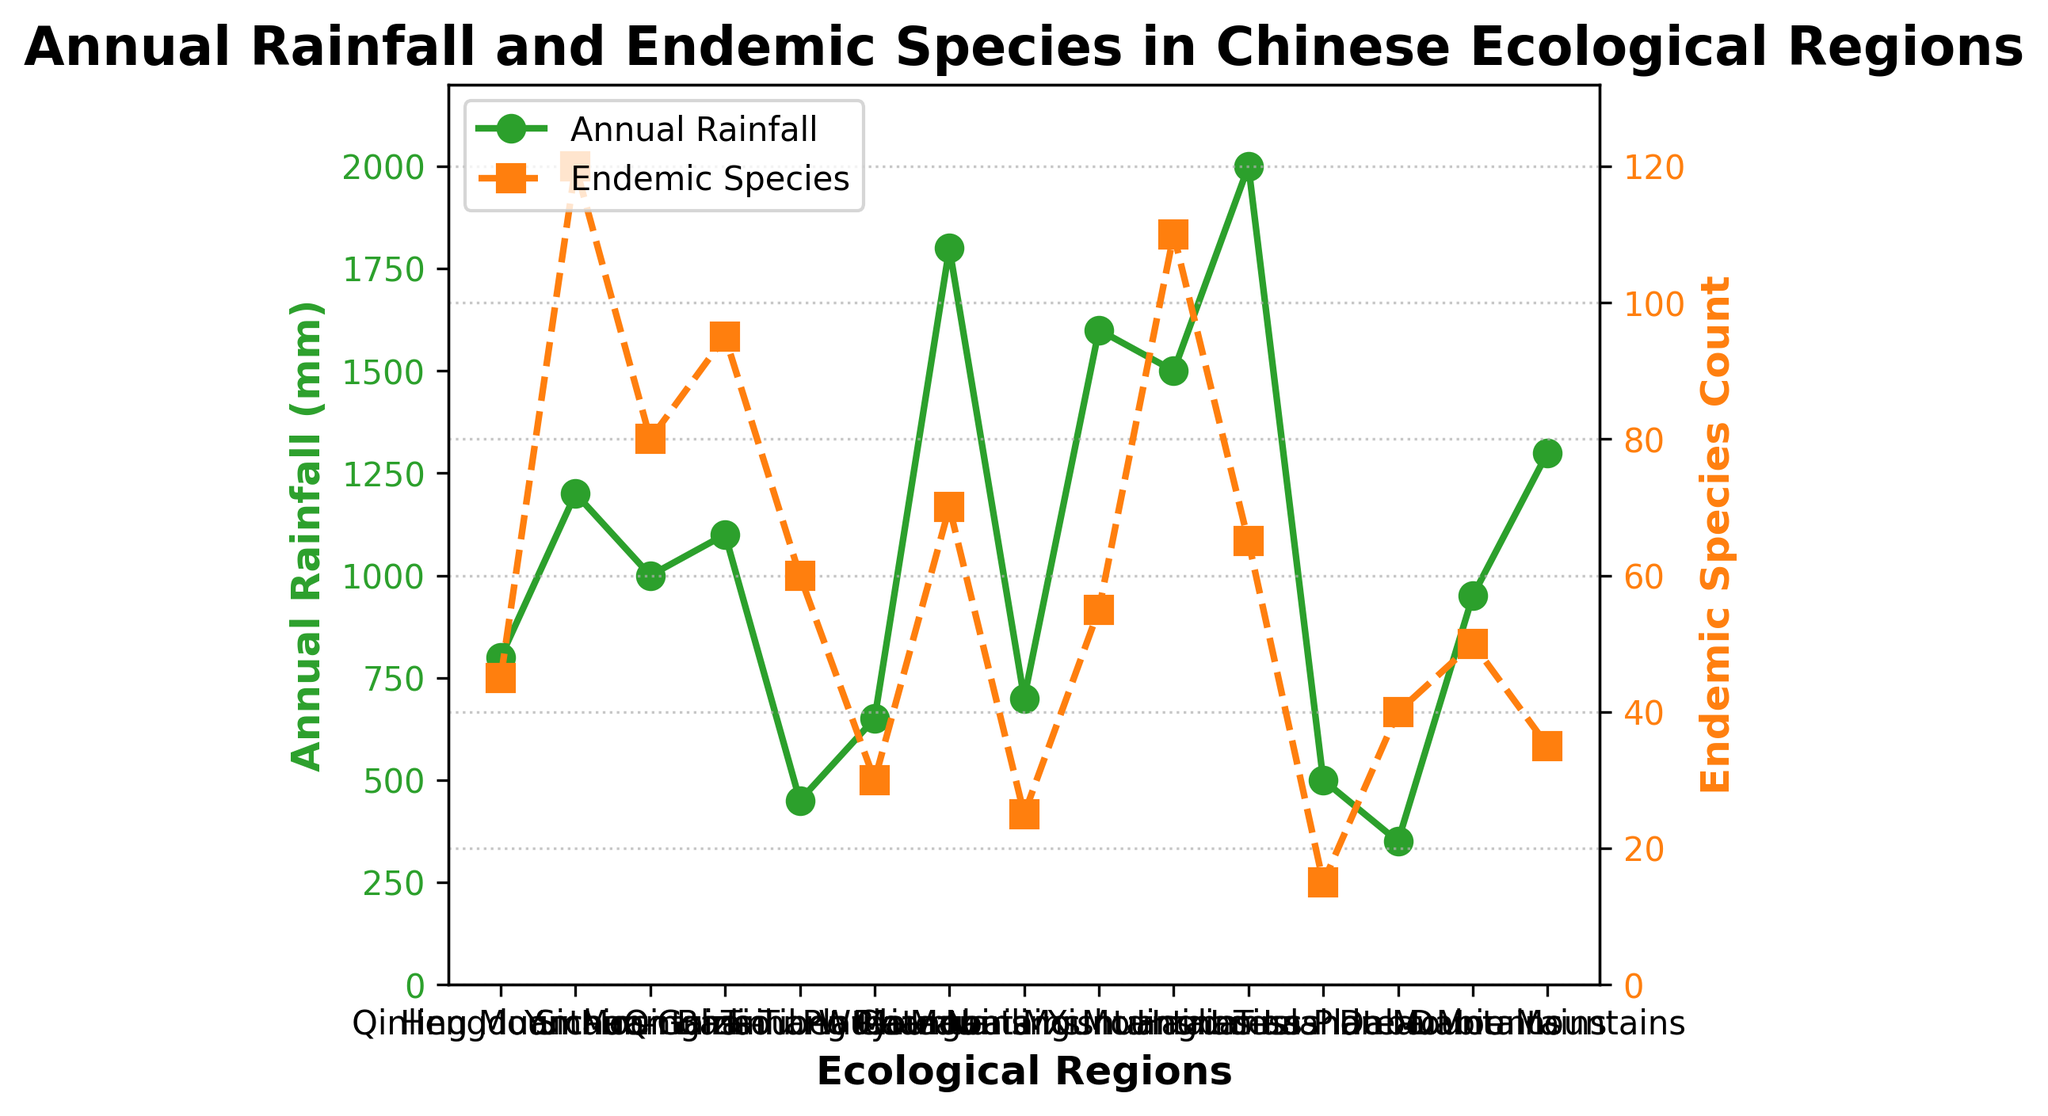What region has the highest annual rainfall? The region with the highest annual rainfall is Hainan Island. From the left axis representing annual rainfall in green, Hainan Island has the bar reaching the 2000 mm mark.
Answer: Hainan Island Which region has the lowest count of endemic species? The region with the lowest count of endemic species is Loess Plateau. From the right axis representing endemic species count in orange, Loess Plateau has the bar reaching only the 15 species mark.
Answer: Loess Plateau What is the difference in annual rainfall between the Hengduan Mountains and the Qinghai-Tibet Plateau? The Hengduan Mountains have an annual rainfall of 1200 mm, while the Qinghai-Tibet Plateau has 450 mm. Subtracting the two values gives 1200 - 450 = 750 mm.
Answer: 750 mm Which regions have both an annual rainfall above 1000 mm and endemic species count above 100? According to the figure, the Hengduan Mountains and Xishuangbanna have annual rainfall above 1000 mm and an endemic species count above 100, as indicated by the green and orange lines respectively.
Answer: Hengduan Mountains, Xishuangbanna Compare the annual rainfall of the Wuyi Mountains and the Nanling Mountains. Which one has more, and by how much? The Wuyi Mountains have an annual rainfall of 1800 mm, and the Nanling Mountains have 1600 mm. The difference is 1800 - 1600 = 200 mm, so the Wuyi Mountains have 200 mm more rainfall.
Answer: Wuyi Mountains, 200 mm How many regions have an endemic species count greater than 50? Based on the orange line on the right axis, the regions with an endemic species count greater than 50 are Qinling Mountains, Hengduan Mountains, Sichuan Basin, Yunnan-Guizhou Plateau, Qinghai-Tibet Plateau, Xishuangbanna, Nanling Mountains, Hainan Island, and Daba Mountains. Counting these, there are 9 regions.
Answer: 9 regions What’s the sum of endemic species counts of regions with annual rainfall less than 1000 mm? The regions with annual rainfall less than 1000 mm are Qinghai-Tibet Plateau (60 endemic species), Taihang Mountains (30 endemic species), Changbai Mountains (25 endemic species), Loess Plateau (15 endemic species), and Tianshan Mountains (40 endemic species). The sum is 60 + 30 + 25 + 15 + 40 = 170.
Answer: 170 Which region has a greater disparity between annual rainfall and endemic species count, the Dabie Mountains or the Tianshan Mountains? The Dabie Mountains have an annual rainfall of 1300 mm and an endemic species count of 35, a difference of 1300 - 35 = 1265 mm. The Tianshan Mountains have an annual rainfall of 350 mm and an endemic species count of 40, a difference of 350 - 40 = 310 mm. Therefore, Dabie Mountains have a greater disparity.
Answer: Dabie Mountains, 1265 mm 